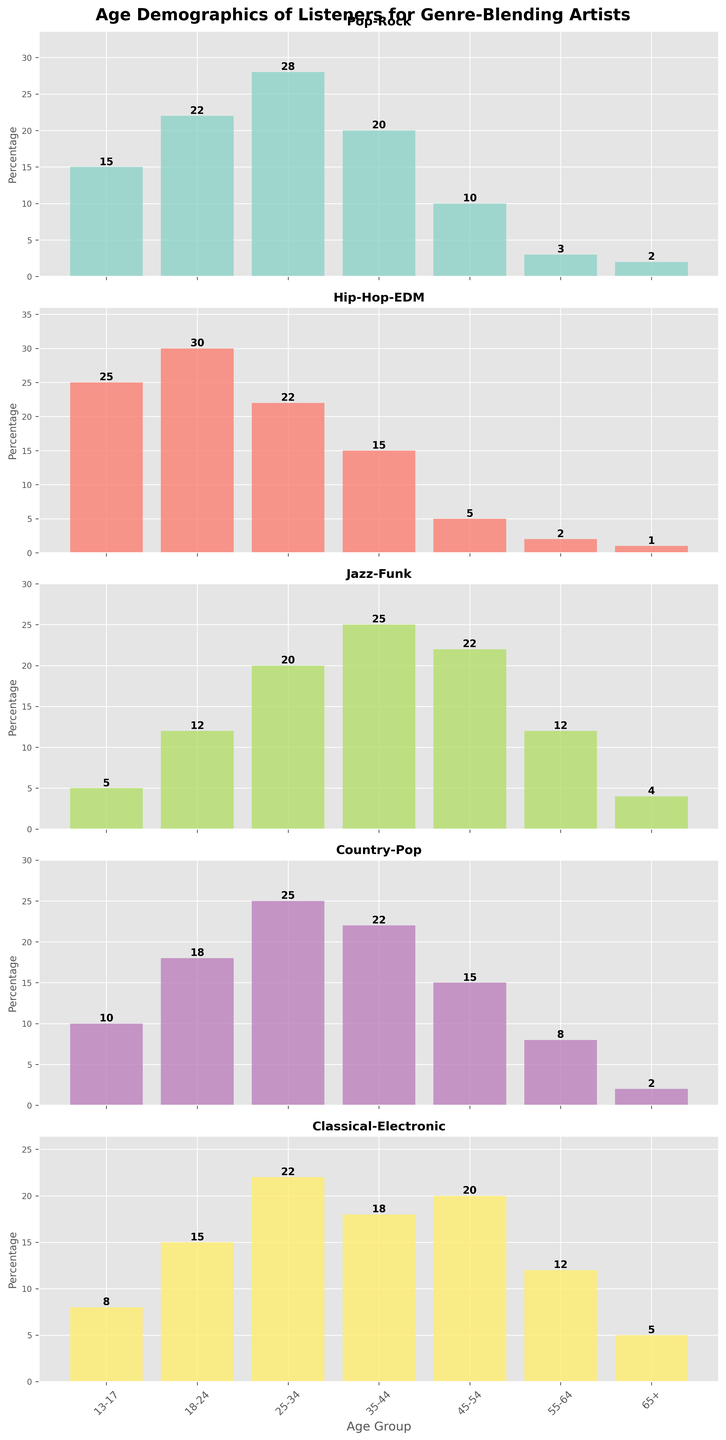what age group listens to Hip-Hop-EDM the most? The subplot for Hip-Hop-EDM shows a bar chart where the height of the bar for the age group 18-24 is the tallest, indicating it's the most popular among this age group.
Answer: 18-24 Which genre blends have the highest number of listeners in the 25-34 age group? By observing the subplot for each genre blend, the highest bar in the 25-34 age group is from the Pop-Rock subplot, showing the number 28.
Answer: Pop-Rock Compare the 45-54 age group's interest in Jazz-Funk and Classical-Electronic. Which has more listeners? The subplot for Jazz-Funk shows a bar of height 22 for the 45-54 age group, while Classical-Electronic shows a bar of height 20. Therefore, Jazz-Funk has more listeners.
Answer: Jazz-Funk What is the average percentage of listeners aged 35-44 across all genre blends? Sum the percentages for the 35-44 age group across all genre blends: 20 (Pop-Rock) + 15 (Hip-Hop-EDM) + 25 (Jazz-Funk) + 22 (Country-Pop) + 18 (Classical-Electronic) = 100. Then divide by 5 genres: 100 / 5 = 20.
Answer: 20 What is the difference in listener percentages between the 13-17 and 55-64 age groups for Country-Pop? The subplot for Country-Pop shows 10 for the 13-17 age group and 8 for the 55-64 age group. The difference is 10 - 8 = 2.
Answer: 2 Which age group shows the lowest interest in Pop-Rock? The Pop-Rock subplot highlights the lowest bar for the 65+ age group with a percentage of 2.
Answer: 65+ How does the popularity of Classical-Electronic among the 18-24 age group compare to its popularity among the 45-54 age group? The subplot for Classical-Electronic shows a bar with a height of 15 for the 18-24 age group and a bar of height 20 for the 45-54 age group. The 45-54 age group shows greater interest.
Answer: 45-54 What is the sum of the percentages of listeners aged 13-17 and aged 18-24 for Jazz-Funk? The subplot for Jazz-Funk shows 5 for the 13-17 age group and 12 for the 18-24 age group. The sum is 5 + 12 = 17.
Answer: 17 Compare the height of bars for Pop-Rock and Hip-Hop-EDM in the 25-34 age group. Which one is taller? Observing the subplots, the bar for Pop-Rock in the 25-34 age group (28) is taller than that for Hip-Hop-EDM (22).
Answer: Pop-Rock 